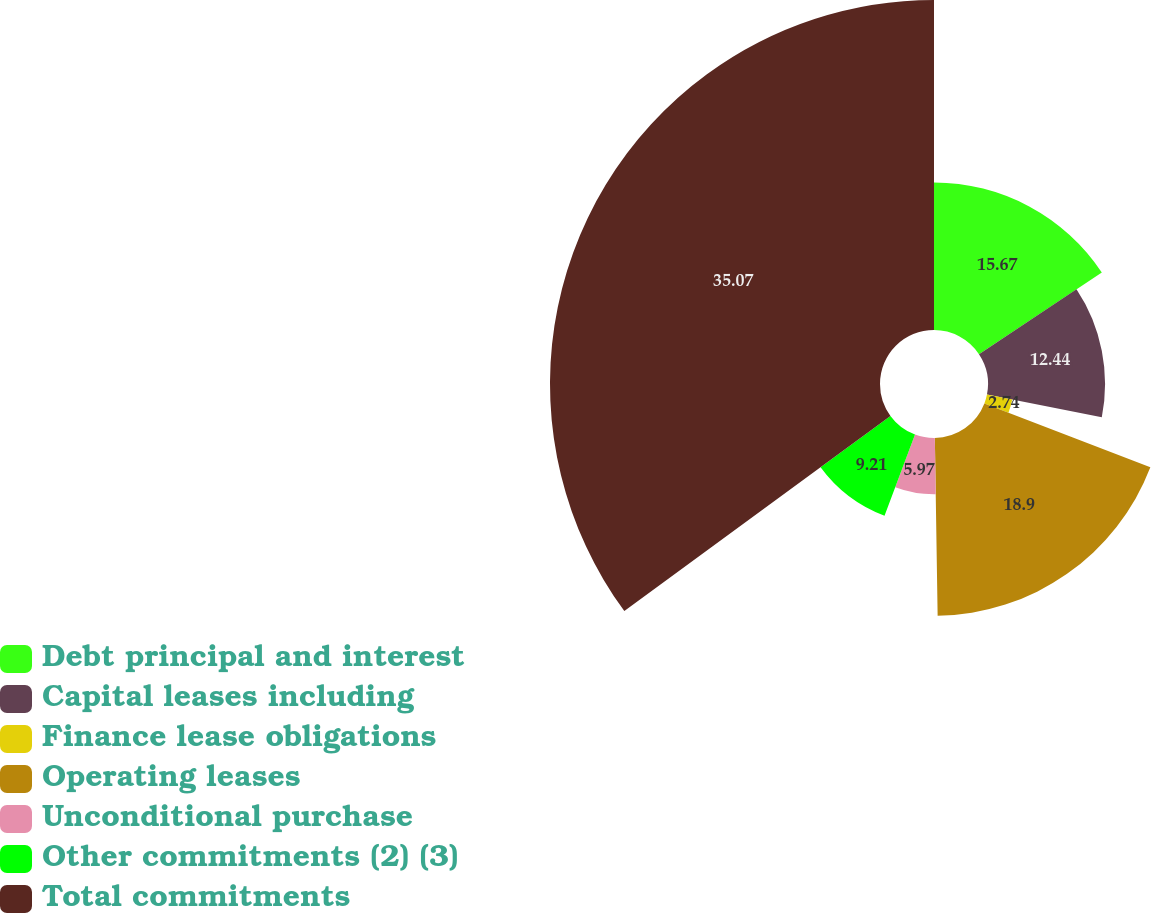<chart> <loc_0><loc_0><loc_500><loc_500><pie_chart><fcel>Debt principal and interest<fcel>Capital leases including<fcel>Finance lease obligations<fcel>Operating leases<fcel>Unconditional purchase<fcel>Other commitments (2) (3)<fcel>Total commitments<nl><fcel>15.67%<fcel>12.44%<fcel>2.74%<fcel>18.9%<fcel>5.97%<fcel>9.21%<fcel>35.07%<nl></chart> 